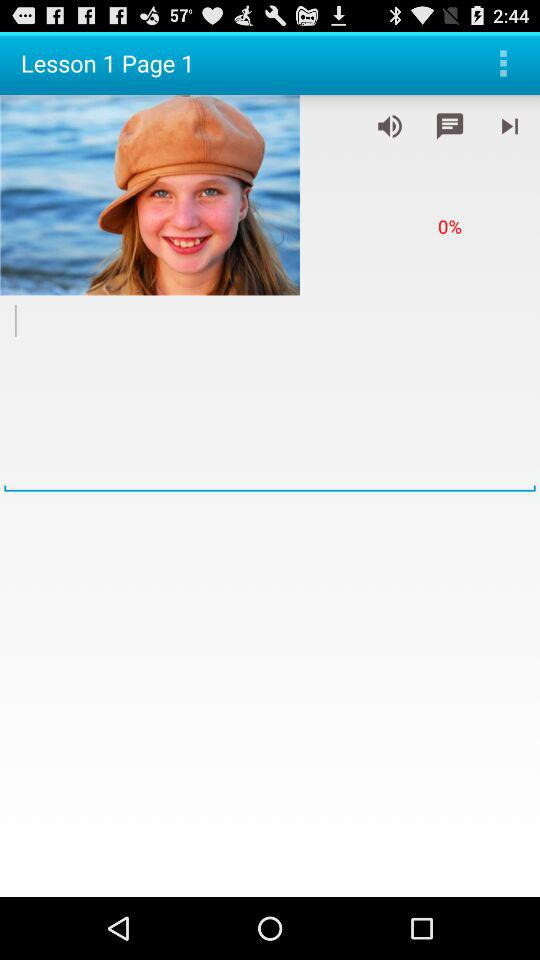How much volume is currently set?
Answer the question using a single word or phrase. 0% 